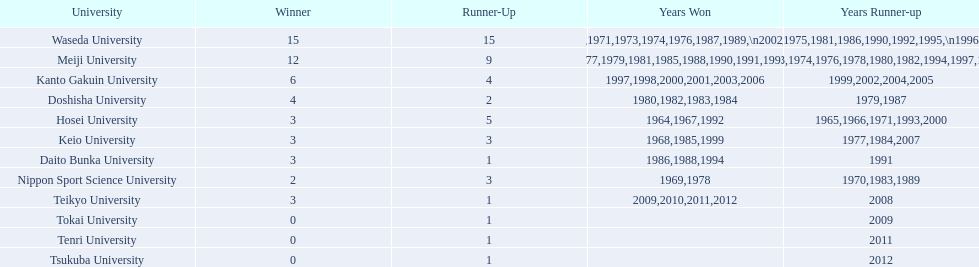Who emerged as the winner in the subsequent year? Waseda University. 